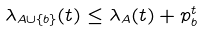<formula> <loc_0><loc_0><loc_500><loc_500>\lambda _ { A \cup \{ b \} } ( t ) \leq \lambda _ { A } ( t ) + p _ { b } ^ { t }</formula> 